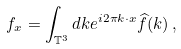<formula> <loc_0><loc_0><loc_500><loc_500>f _ { x } = \int _ { \mathbb { T } ^ { 3 } } d k e ^ { i 2 \pi k \cdot x } \widehat { f } ( k ) \, ,</formula> 